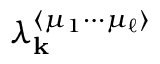<formula> <loc_0><loc_0><loc_500><loc_500>\lambda _ { k } ^ { \langle \mu _ { 1 } \cdots \mu _ { \ell } \rangle }</formula> 